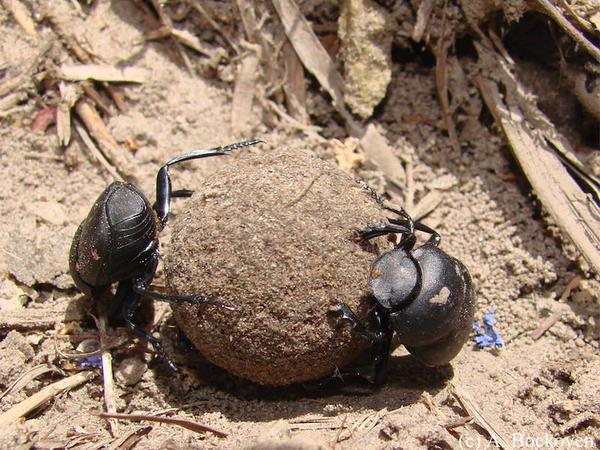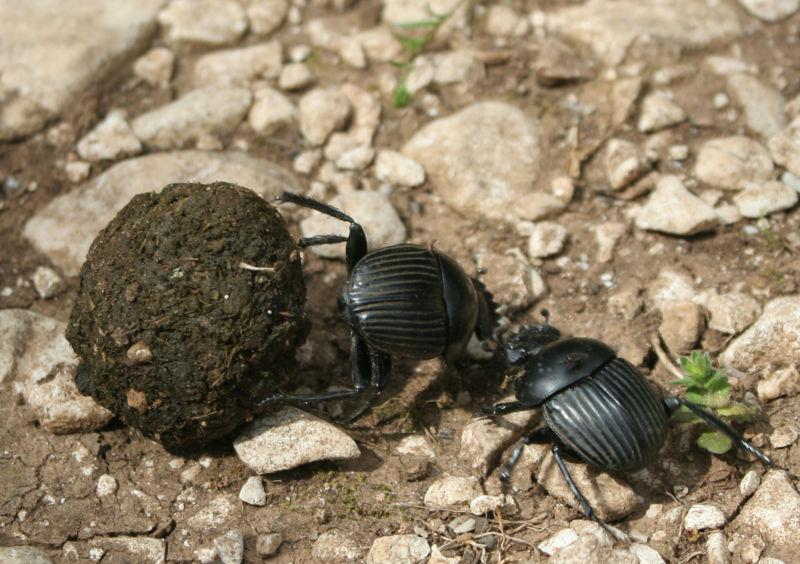The first image is the image on the left, the second image is the image on the right. Examine the images to the left and right. Is the description "There are two black beetles in total." accurate? Answer yes or no. No. 